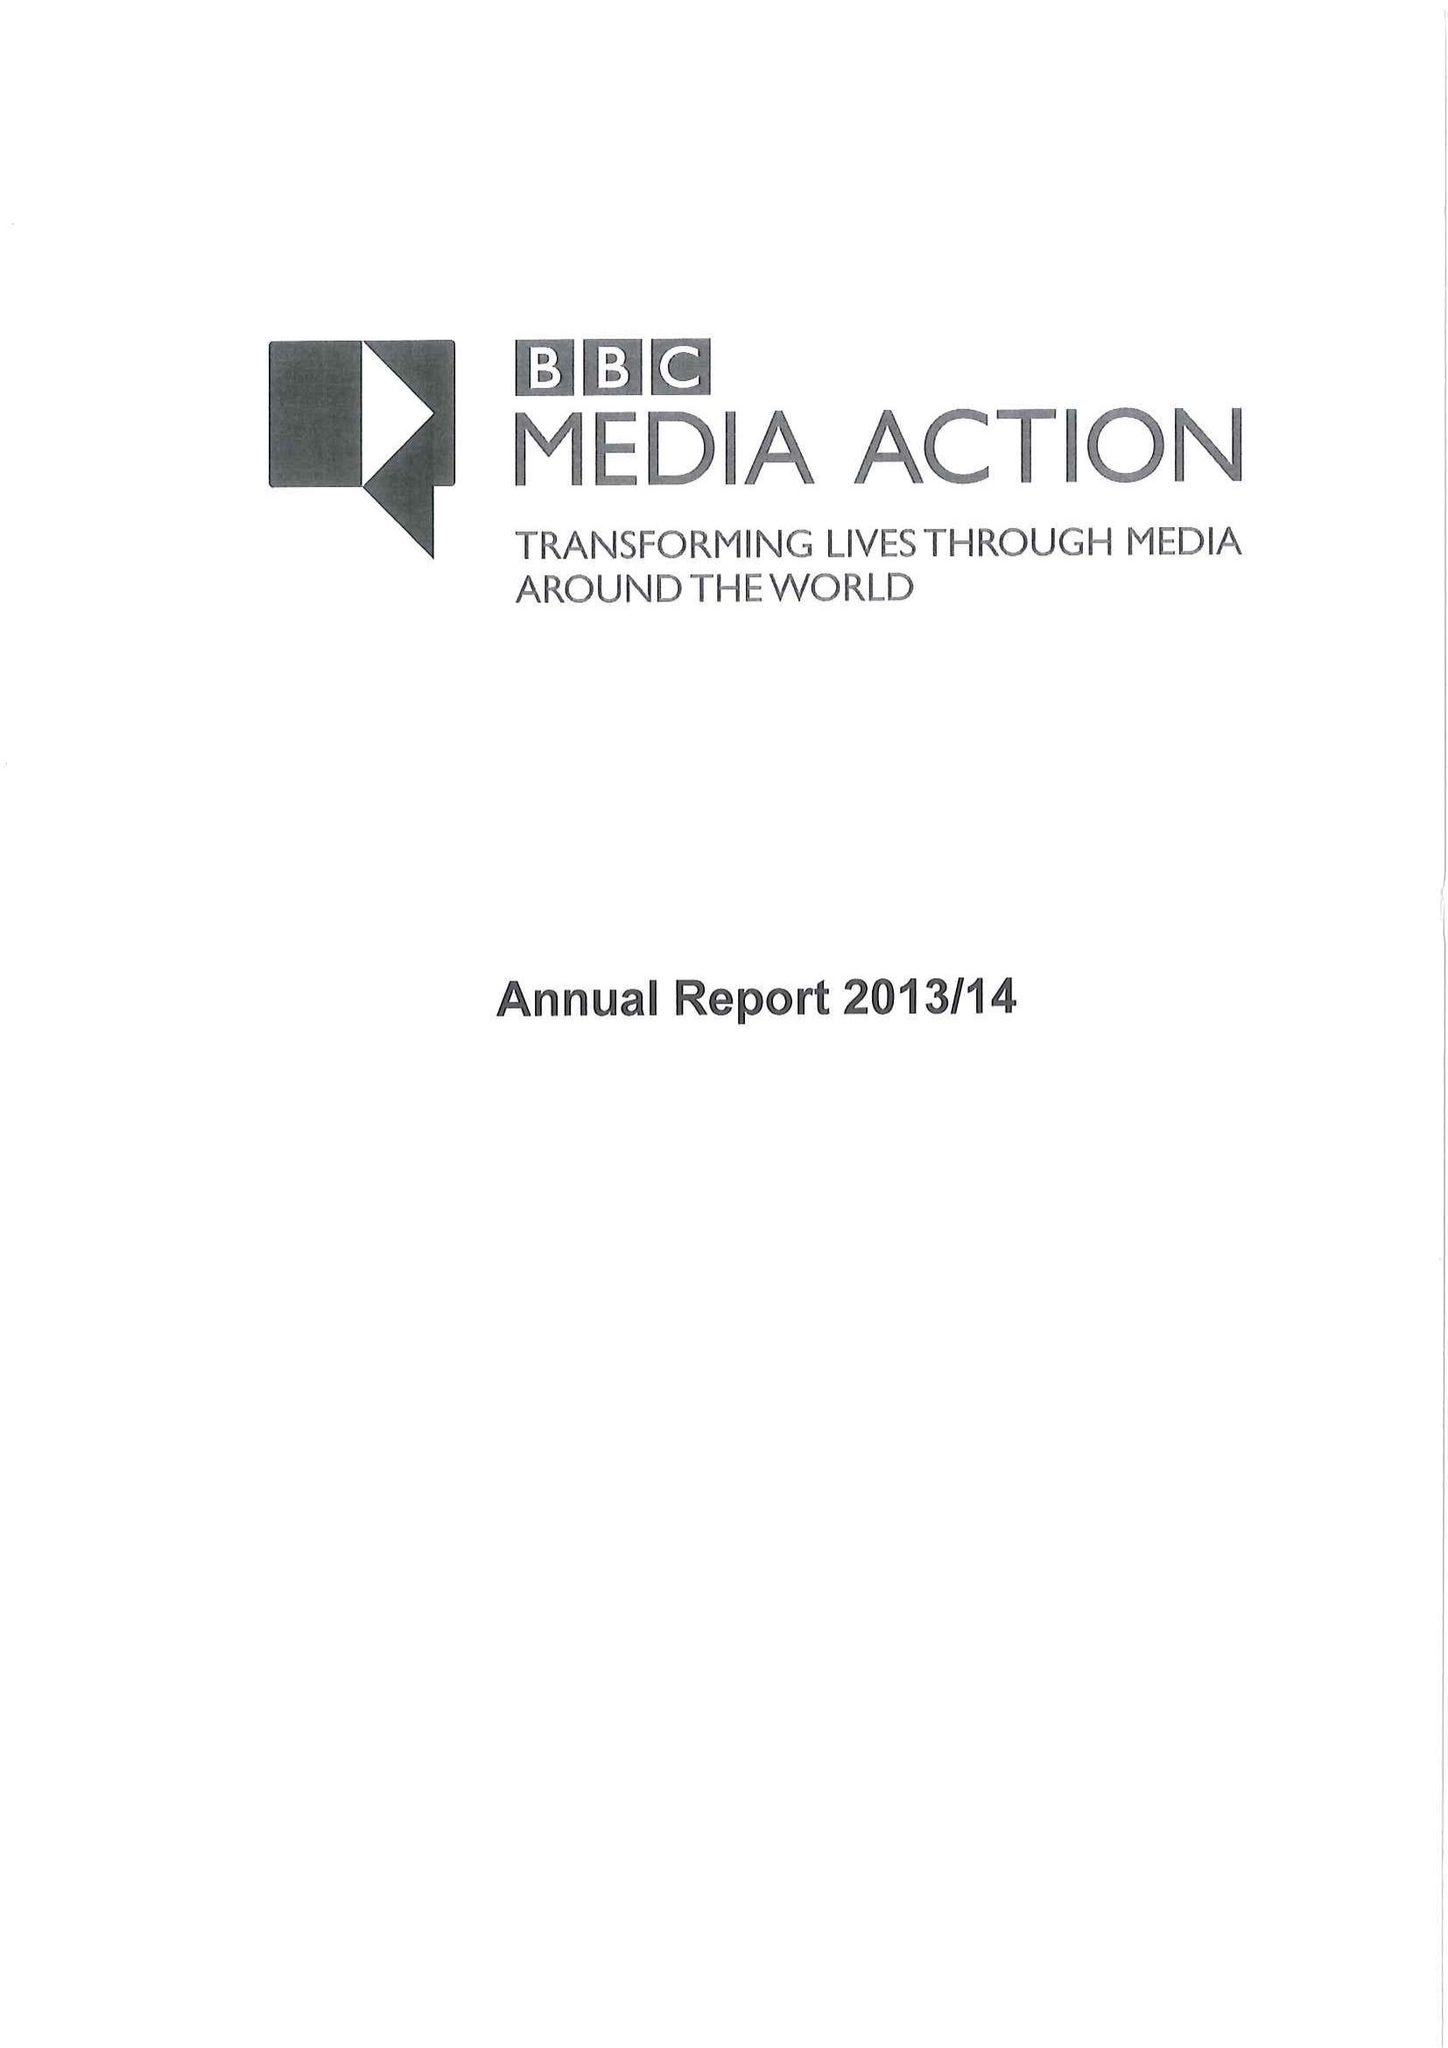What is the value for the income_annually_in_british_pounds?
Answer the question using a single word or phrase. 40381000.00 